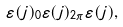Convert formula to latex. <formula><loc_0><loc_0><loc_500><loc_500>\varepsilon ( j ) _ { 0 } \varepsilon ( j ) _ { 2 \pi } \varepsilon ( j ) ,</formula> 